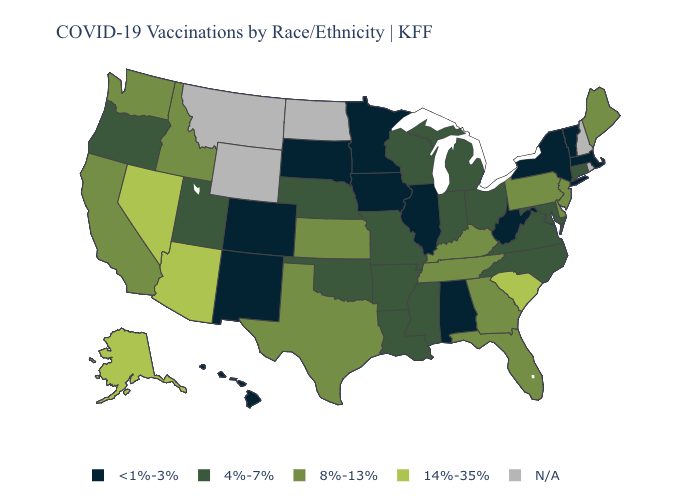Name the states that have a value in the range 14%-35%?
Be succinct. Alaska, Arizona, Nevada, South Carolina. Does the first symbol in the legend represent the smallest category?
Be succinct. Yes. Among the states that border Florida , does Georgia have the highest value?
Short answer required. Yes. What is the value of Idaho?
Quick response, please. 8%-13%. What is the value of Wisconsin?
Keep it brief. 4%-7%. Does Nebraska have the highest value in the MidWest?
Keep it brief. No. What is the highest value in the USA?
Concise answer only. 14%-35%. What is the value of Kansas?
Quick response, please. 8%-13%. Name the states that have a value in the range 14%-35%?
Quick response, please. Alaska, Arizona, Nevada, South Carolina. Does Alabama have the lowest value in the South?
Answer briefly. Yes. What is the lowest value in the Northeast?
Quick response, please. <1%-3%. What is the lowest value in the West?
Quick response, please. <1%-3%. How many symbols are there in the legend?
Concise answer only. 5. 